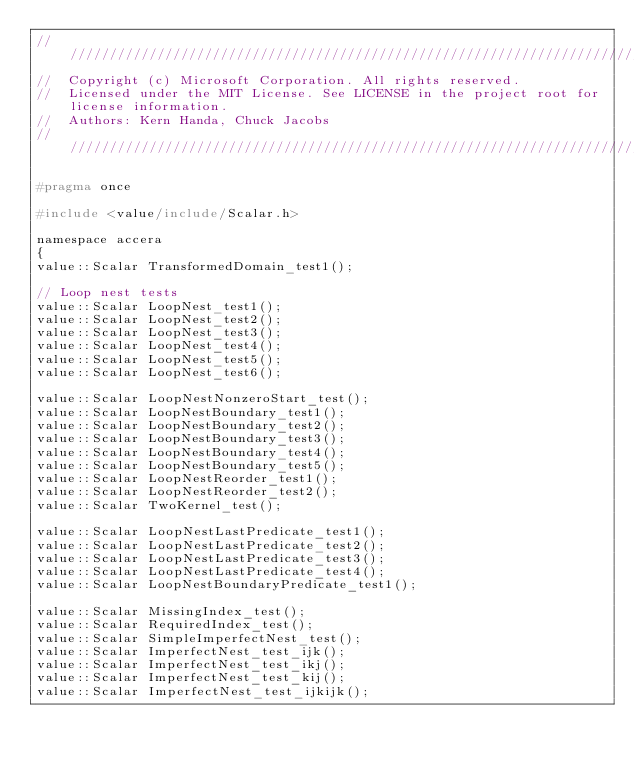<code> <loc_0><loc_0><loc_500><loc_500><_C_>////////////////////////////////////////////////////////////////////////////////////////////////////
//  Copyright (c) Microsoft Corporation. All rights reserved.
//  Licensed under the MIT License. See LICENSE in the project root for license information.
//  Authors: Kern Handa, Chuck Jacobs
////////////////////////////////////////////////////////////////////////////////////////////////////

#pragma once

#include <value/include/Scalar.h>

namespace accera
{
value::Scalar TransformedDomain_test1();

// Loop nest tests
value::Scalar LoopNest_test1();
value::Scalar LoopNest_test2();
value::Scalar LoopNest_test3();
value::Scalar LoopNest_test4();
value::Scalar LoopNest_test5();
value::Scalar LoopNest_test6();

value::Scalar LoopNestNonzeroStart_test();
value::Scalar LoopNestBoundary_test1();
value::Scalar LoopNestBoundary_test2();
value::Scalar LoopNestBoundary_test3();
value::Scalar LoopNestBoundary_test4();
value::Scalar LoopNestBoundary_test5();
value::Scalar LoopNestReorder_test1();
value::Scalar LoopNestReorder_test2();
value::Scalar TwoKernel_test();

value::Scalar LoopNestLastPredicate_test1();
value::Scalar LoopNestLastPredicate_test2();
value::Scalar LoopNestLastPredicate_test3();
value::Scalar LoopNestLastPredicate_test4();
value::Scalar LoopNestBoundaryPredicate_test1();

value::Scalar MissingIndex_test();
value::Scalar RequiredIndex_test();
value::Scalar SimpleImperfectNest_test();
value::Scalar ImperfectNest_test_ijk();
value::Scalar ImperfectNest_test_ikj();
value::Scalar ImperfectNest_test_kij();
value::Scalar ImperfectNest_test_ijkijk();</code> 